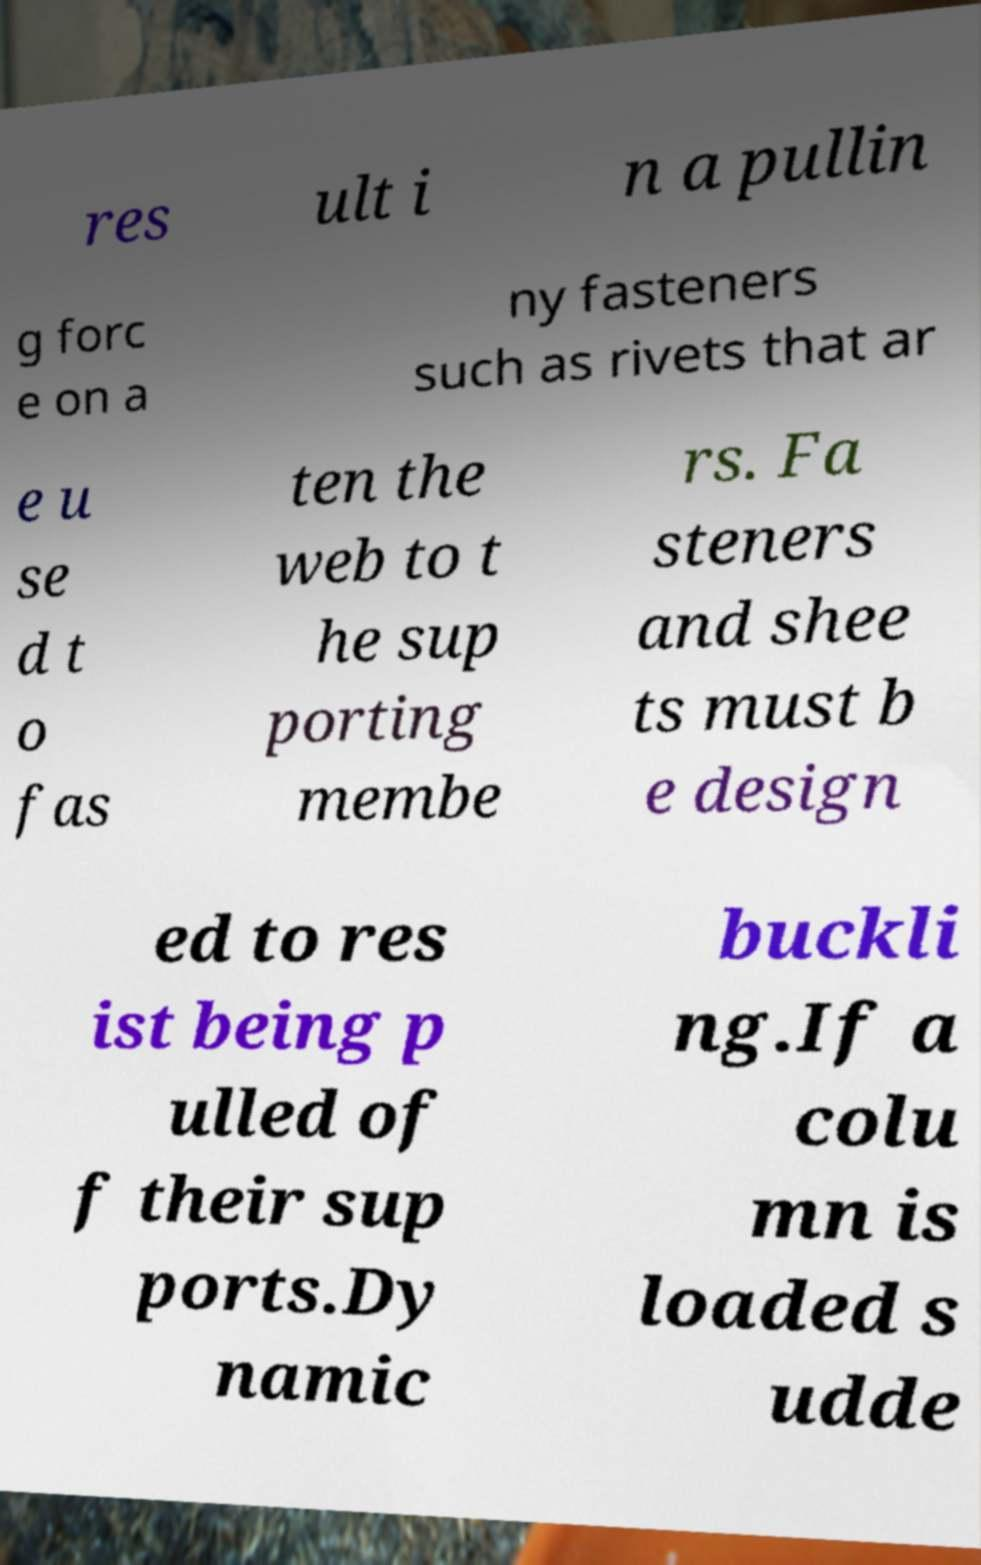There's text embedded in this image that I need extracted. Can you transcribe it verbatim? res ult i n a pullin g forc e on a ny fasteners such as rivets that ar e u se d t o fas ten the web to t he sup porting membe rs. Fa steners and shee ts must b e design ed to res ist being p ulled of f their sup ports.Dy namic buckli ng.If a colu mn is loaded s udde 